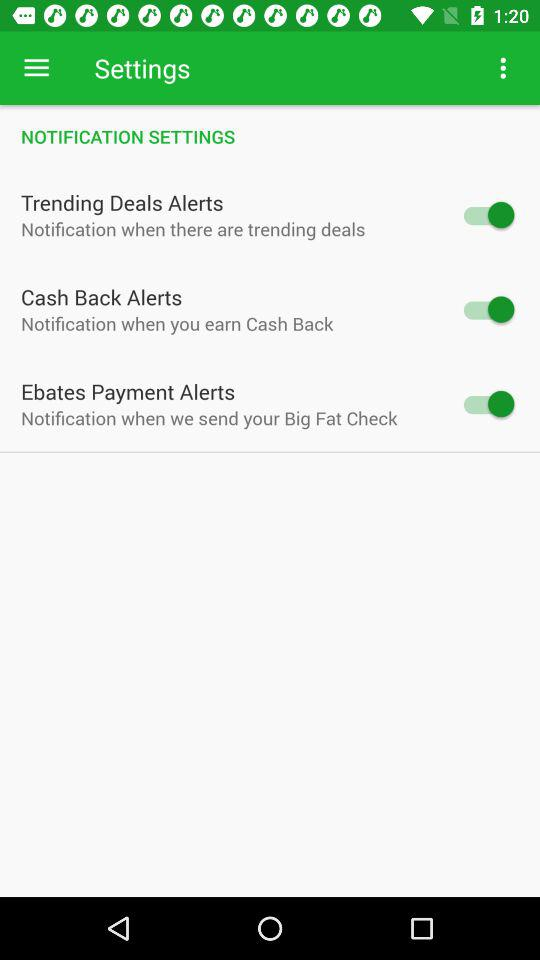What is the current status of "Trending Deals Alerts"? The current status of "Trending Deals Alerts" is "on". 